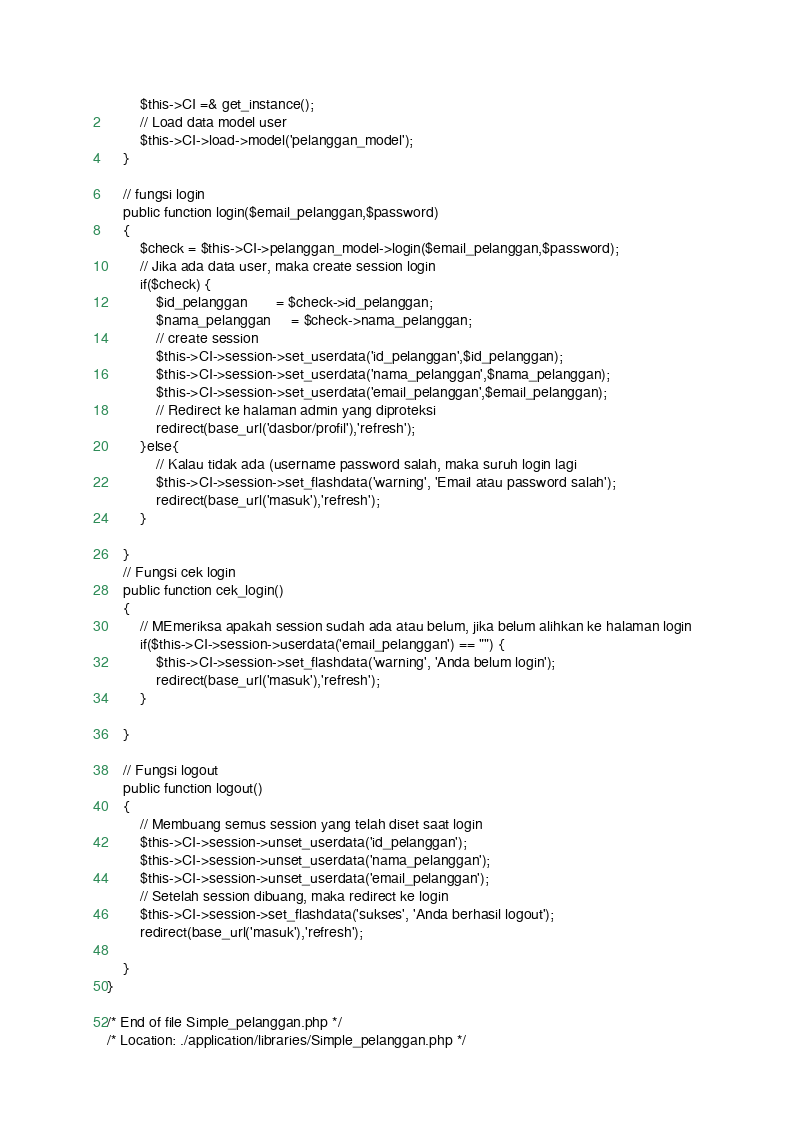<code> <loc_0><loc_0><loc_500><loc_500><_PHP_>        $this->CI =& get_instance();
        // Load data model user
        $this->CI->load->model('pelanggan_model');
	}

	// fungsi login
	public function login($email_pelanggan,$password)
	{
		$check = $this->CI->pelanggan_model->login($email_pelanggan,$password);
		// Jika ada data user, maka create session login
		if($check) {
			$id_pelanggan		= $check->id_pelanggan;
			$nama_pelanggan		= $check->nama_pelanggan;
			// create session
			$this->CI->session->set_userdata('id_pelanggan',$id_pelanggan);
			$this->CI->session->set_userdata('nama_pelanggan',$nama_pelanggan);
			$this->CI->session->set_userdata('email_pelanggan',$email_pelanggan);
			// Redirect ke halaman admin yang diproteksi
			redirect(base_url('dasbor/profil'),'refresh');
		}else{
			// Kalau tidak ada (username password salah, maka suruh login lagi
			$this->CI->session->set_flashdata('warning', 'Email atau password salah');
			redirect(base_url('masuk'),'refresh');
		}

	}
	// Fungsi cek login
	public function cek_login()
	{
		// MEmeriksa apakah session sudah ada atau belum, jika belum alihkan ke halaman login
		if($this->CI->session->userdata('email_pelanggan') == "") {
			$this->CI->session->set_flashdata('warning', 'Anda belum login');
			redirect(base_url('masuk'),'refresh');
		}

	}

	// Fungsi logout
	public function logout()
	{
		// Membuang semus session yang telah diset saat login
		$this->CI->session->unset_userdata('id_pelanggan');
		$this->CI->session->unset_userdata('nama_pelanggan');
		$this->CI->session->unset_userdata('email_pelanggan');
		// Setelah session dibuang, maka redirect ke login
		$this->CI->session->set_flashdata('sukses', 'Anda berhasil logout');
		redirect(base_url('masuk'),'refresh');

	}	
}

/* End of file Simple_pelanggan.php */
/* Location: ./application/libraries/Simple_pelanggan.php */
</code> 